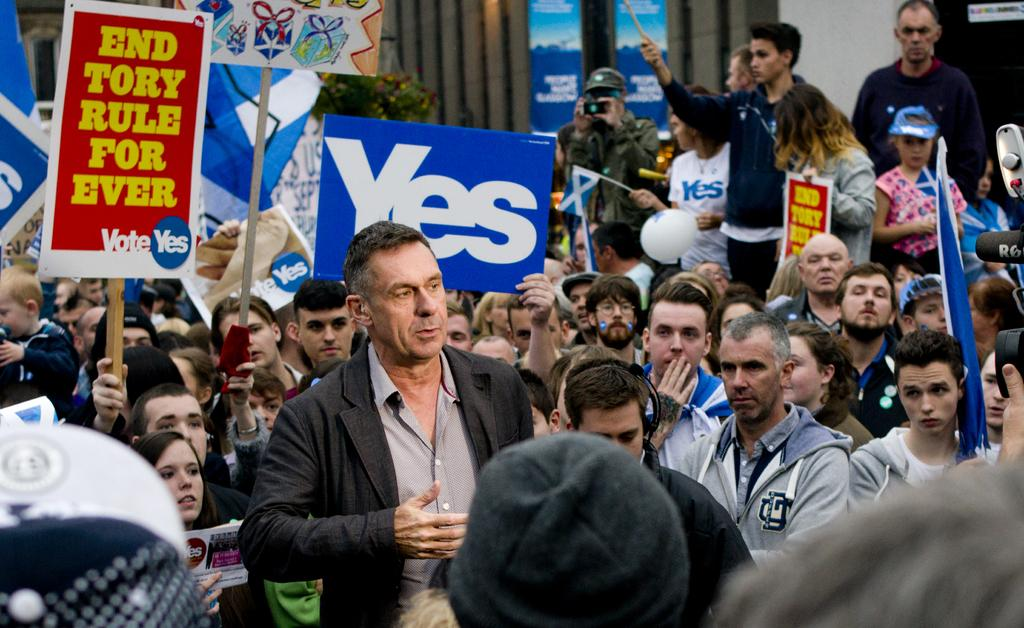What is happening in the image? There are people standing in the image. What are some of the people holding? Some of the people are holding boards. What can be seen in the background of the image? There is a building and a tree visible in the background of the image. What else is present in the image? There are flags present in the image. How many dolls are sitting on the quilt in the image? There are no dolls or quilts present in the image. 